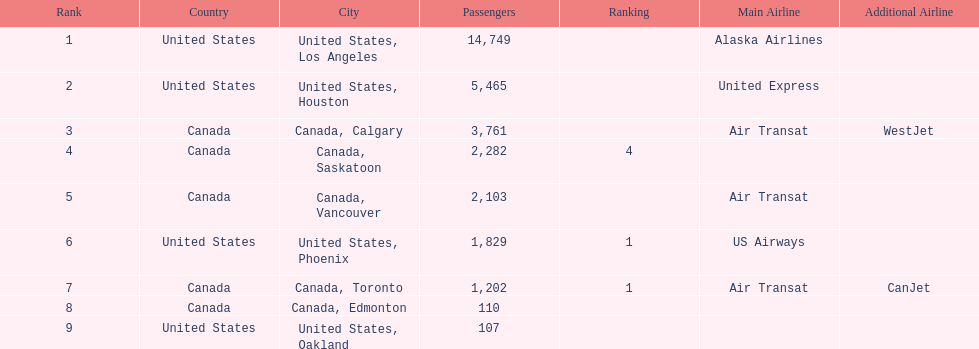What was the number of passengers in phoenix arizona? 1,829. 